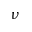Convert formula to latex. <formula><loc_0><loc_0><loc_500><loc_500>\nu</formula> 